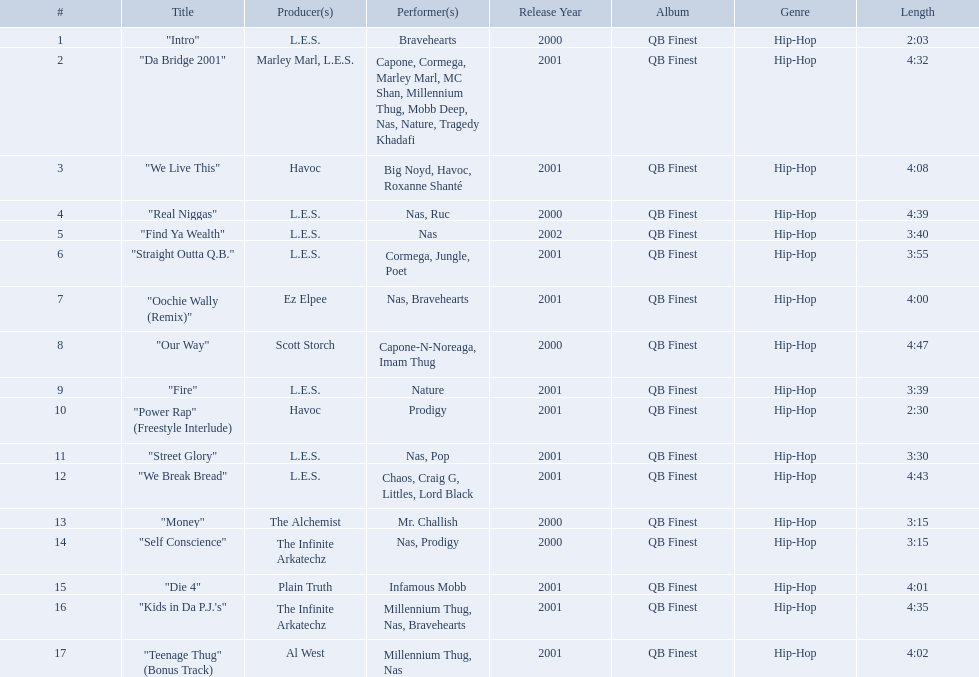What are all the song titles? "Intro", "Da Bridge 2001", "We Live This", "Real Niggas", "Find Ya Wealth", "Straight Outta Q.B.", "Oochie Wally (Remix)", "Our Way", "Fire", "Power Rap" (Freestyle Interlude), "Street Glory", "We Break Bread", "Money", "Self Conscience", "Die 4", "Kids in Da P.J.'s", "Teenage Thug" (Bonus Track). Who produced all these songs? L.E.S., Marley Marl, L.E.S., Ez Elpee, Scott Storch, Havoc, The Alchemist, The Infinite Arkatechz, Plain Truth, Al West. Of the producers, who produced the shortest song? L.E.S. How short was this producer's song? 2:03. 